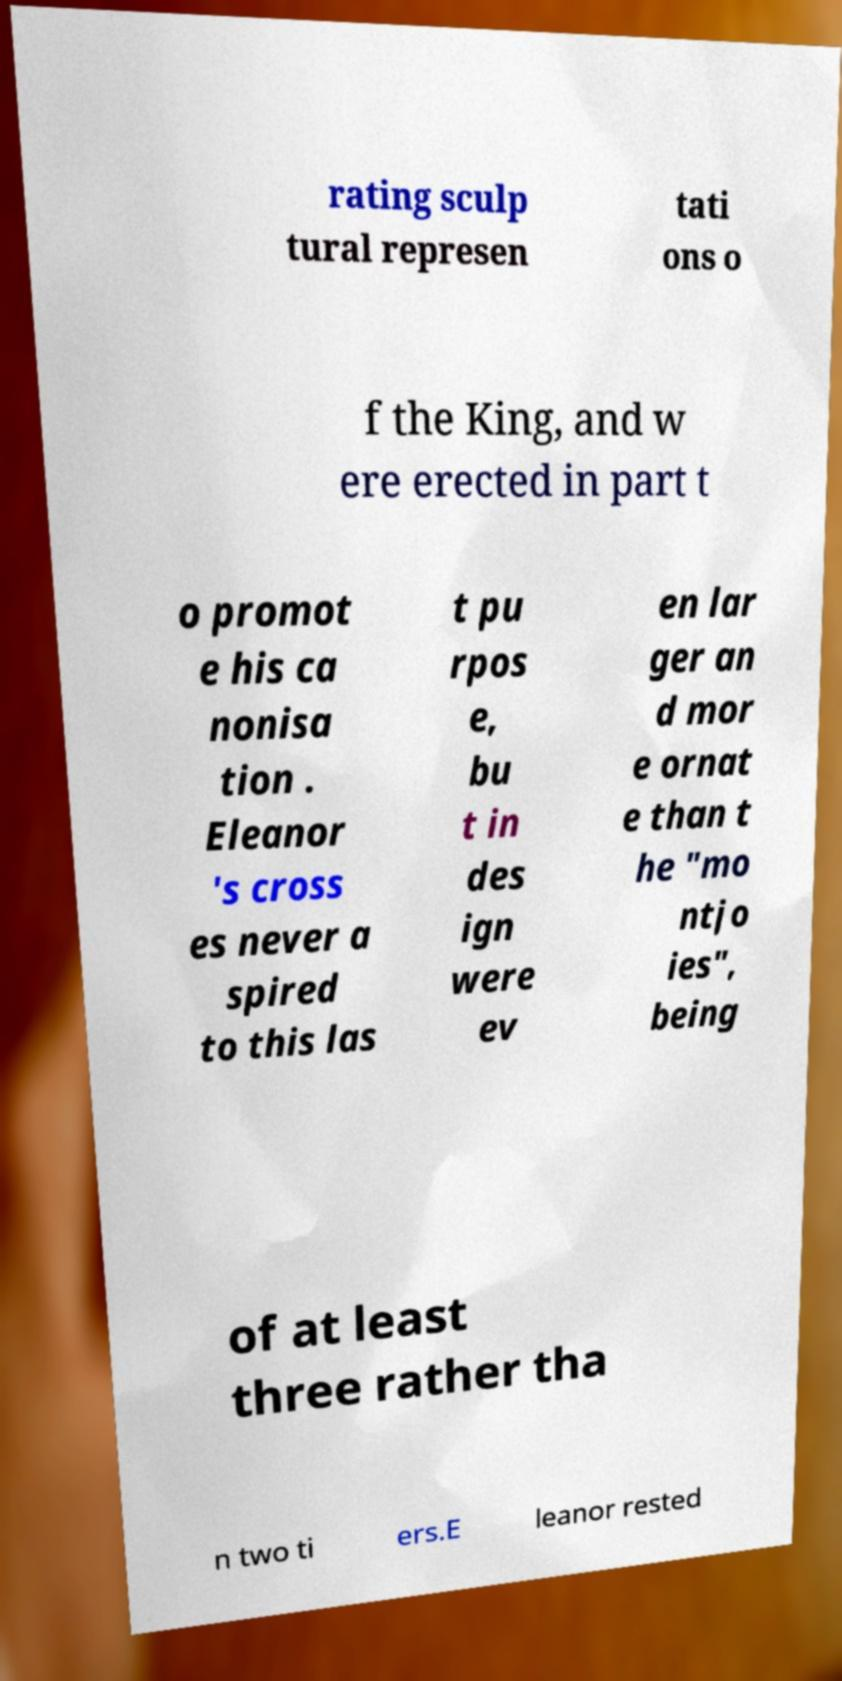Could you extract and type out the text from this image? rating sculp tural represen tati ons o f the King, and w ere erected in part t o promot e his ca nonisa tion . Eleanor 's cross es never a spired to this las t pu rpos e, bu t in des ign were ev en lar ger an d mor e ornat e than t he "mo ntjo ies", being of at least three rather tha n two ti ers.E leanor rested 